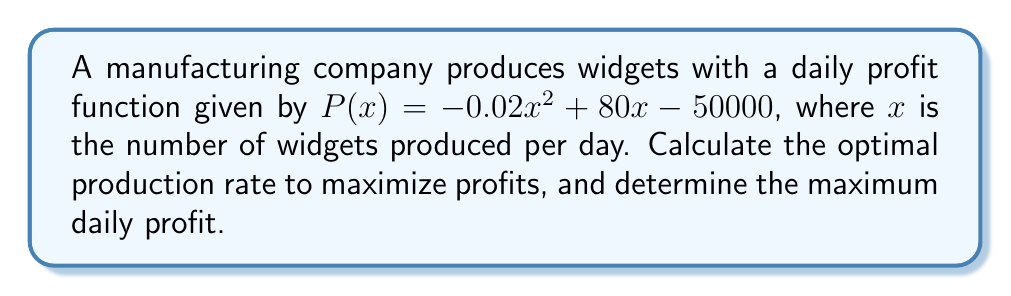Show me your answer to this math problem. To find the optimal production rate and maximum profit, we need to follow these steps:

1. Find the derivative of the profit function:
   $$P'(x) = -0.04x + 80$$

2. Set the derivative equal to zero to find the critical point:
   $$-0.04x + 80 = 0$$
   $$-0.04x = -80$$
   $$x = 2000$$

3. Verify that this critical point is a maximum by checking the second derivative:
   $$P''(x) = -0.04$$
   Since $P''(x)$ is negative, the critical point is a maximum.

4. Calculate the maximum profit by plugging the optimal production rate into the original profit function:
   $$P(2000) = -0.02(2000)^2 + 80(2000) - 50000$$
   $$= -80000 + 160000 - 50000$$
   $$= 30000$$

Therefore, the optimal production rate is 2000 widgets per day, resulting in a maximum daily profit of $30,000.
Answer: Optimal production rate: 2000 widgets/day; Maximum daily profit: $30,000 